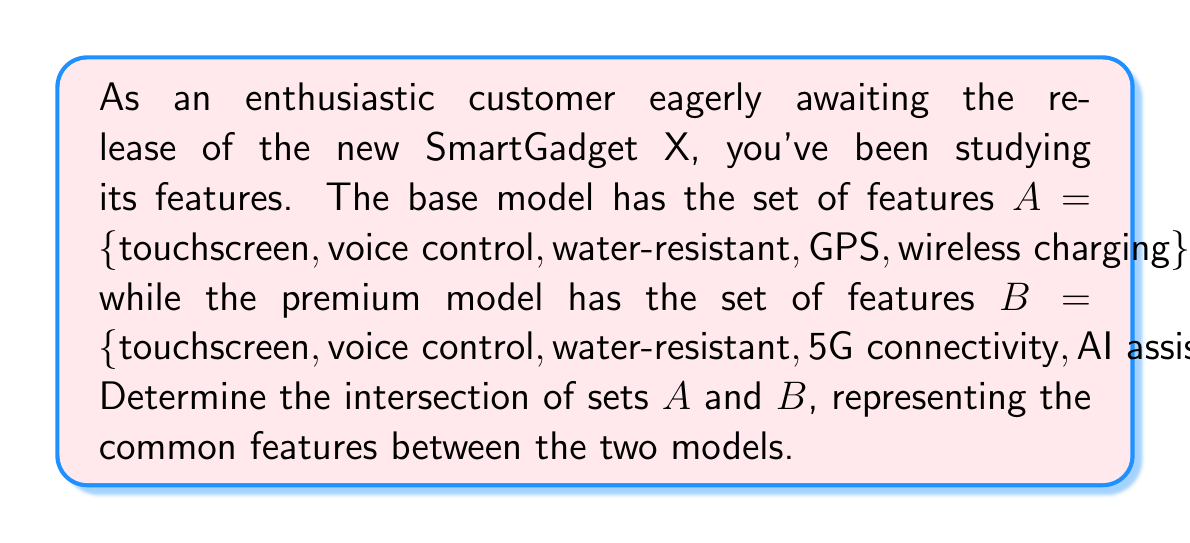Can you solve this math problem? To find the intersection of sets A and B, we need to identify the elements that are present in both sets. Let's follow these steps:

1. List out the elements of each set:
   Set A = {touchscreen, voice control, water-resistant, GPS, wireless charging}
   Set B = {touchscreen, voice control, water-resistant, 5G connectivity, AI assistant}

2. Compare the elements of both sets and identify the common ones:
   - touchscreen: present in both A and B
   - voice control: present in both A and B
   - water-resistant: present in both A and B
   - GPS: only in A
   - wireless charging: only in A
   - 5G connectivity: only in B
   - AI assistant: only in B

3. The intersection of A and B, denoted as $A \cap B$, contains all the elements that are common to both sets.

Therefore, $A \cap B = \{touchscreen, voice control, water-resistant\}$

This can be represented in set-builder notation as:
$$A \cap B = \{x : x \in A \text{ and } x \in B\}$$

Or using a Venn diagram:

[asy]
unitsize(1cm);

pair A = (-1,0), B = (1,0);
real r = 1.5;

fill(circle(A,r), lightblue);
fill(circle(B,r), lightgreen);

draw(circle(A,r));
draw(circle(B,r));

label("A", A + (-0.7,0.7));
label("B", B + (0.7,0.7));

label("touchscreen", (0,0.5));
label("voice control", (0,0));
label("water-resistant", (0,-0.5));

[/asy]

The shaded region in the middle represents the intersection of sets A and B.
Answer: $A \cap B = \{touchscreen, voice control, water-resistant\}$ 